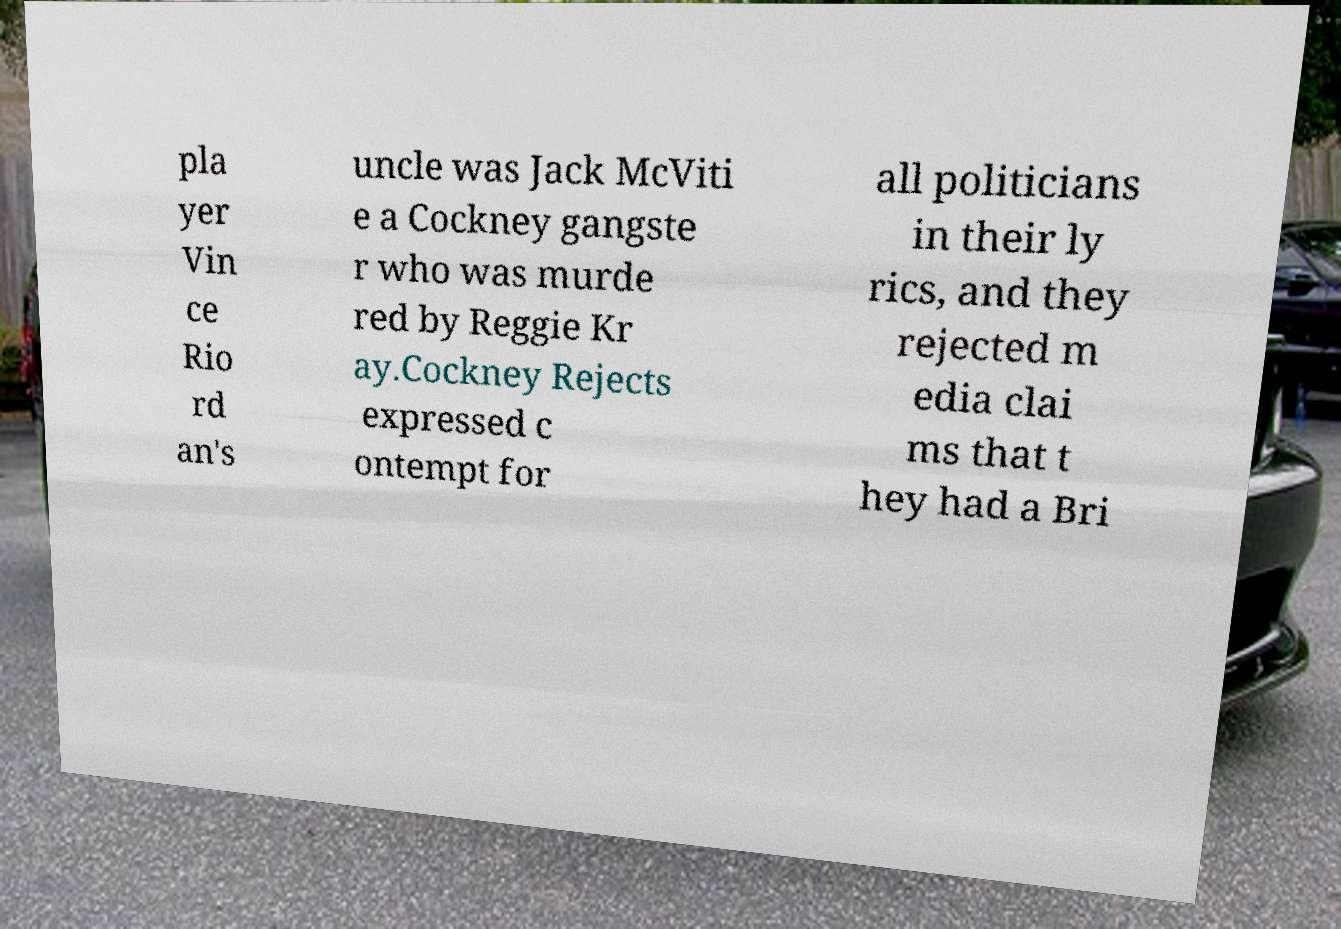Could you assist in decoding the text presented in this image and type it out clearly? pla yer Vin ce Rio rd an's uncle was Jack McViti e a Cockney gangste r who was murde red by Reggie Kr ay.Cockney Rejects expressed c ontempt for all politicians in their ly rics, and they rejected m edia clai ms that t hey had a Bri 